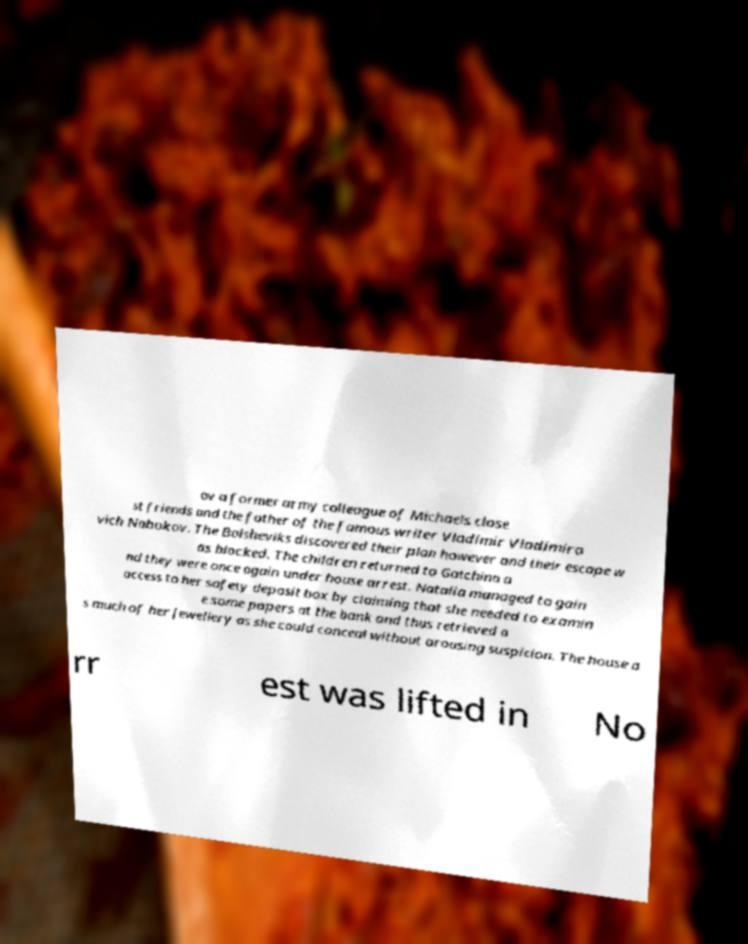Please identify and transcribe the text found in this image. ov a former army colleague of Michaels close st friends and the father of the famous writer Vladimir Vladimiro vich Nabokov. The Bolsheviks discovered their plan however and their escape w as blocked. The children returned to Gatchina a nd they were once again under house arrest. Natalia managed to gain access to her safety deposit box by claiming that she needed to examin e some papers at the bank and thus retrieved a s much of her jewellery as she could conceal without arousing suspicion. The house a rr est was lifted in No 